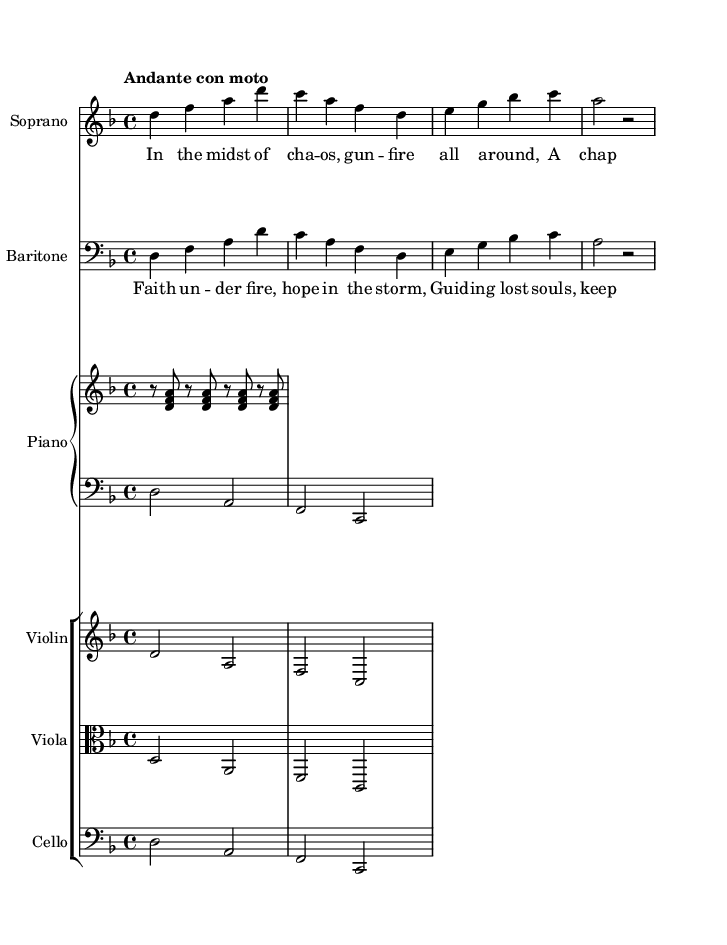What is the key signature of this music? The key signature is indicated by the number of sharps or flats at the beginning of the staff. In this case, there is one flat, showing that the key is D minor.
Answer: D minor What is the time signature of this music? The time signature is presented as two numbers at the beginning of the staff. The top number indicates how many beats are in each measure, and the bottom number indicates the note value that gets one beat. Here, 4/4 means there are four quarter note beats per measure.
Answer: 4/4 What is the tempo marking for this piece? The tempo marking is specified above the staff at the beginning of the music. In this case, it is labeled "Andante con moto," indicating a moderately slow tempo with a little motion.
Answer: Andante con moto What instruments are included in this score? The score shows the specific instruments listed at the beginning of their respective staves. In this piece, there are Soprano, Baritone, Piano, Violin, Viola, and Cello.
Answer: Soprano, Baritone, Piano, Violin, Viola, Cello How many measures are in the soprano part? The number of measures can be counted by looking at how many groups of vertical lines (bar lines) are present in the soprano section. There are four measures counted in the soprano line.
Answer: Four measures What is the text of the soprano's verse? The text can be gathered from the lyrics bracketed underneath the soprano part. The words provided are: "In the midst of chaos, gunfire all around, A chaplain kneels in prayer, upon this hallowed ground."
Answer: In the midst of chaos, gunfire all around, A chaplain kneels in prayer, upon this hallowed ground What does the chorus convey in the context of the opera? The chorus specifically reflects themes of faith and hope amidst hardship, based on the lyrics given: "Faith under fire, hope in the storm, Guiding lost souls, keeping spirits warm." This highlights the role of chaplains in combat situations.
Answer: Faith under fire, hope in the storm, Guiding lost souls, keeping spirits warm 